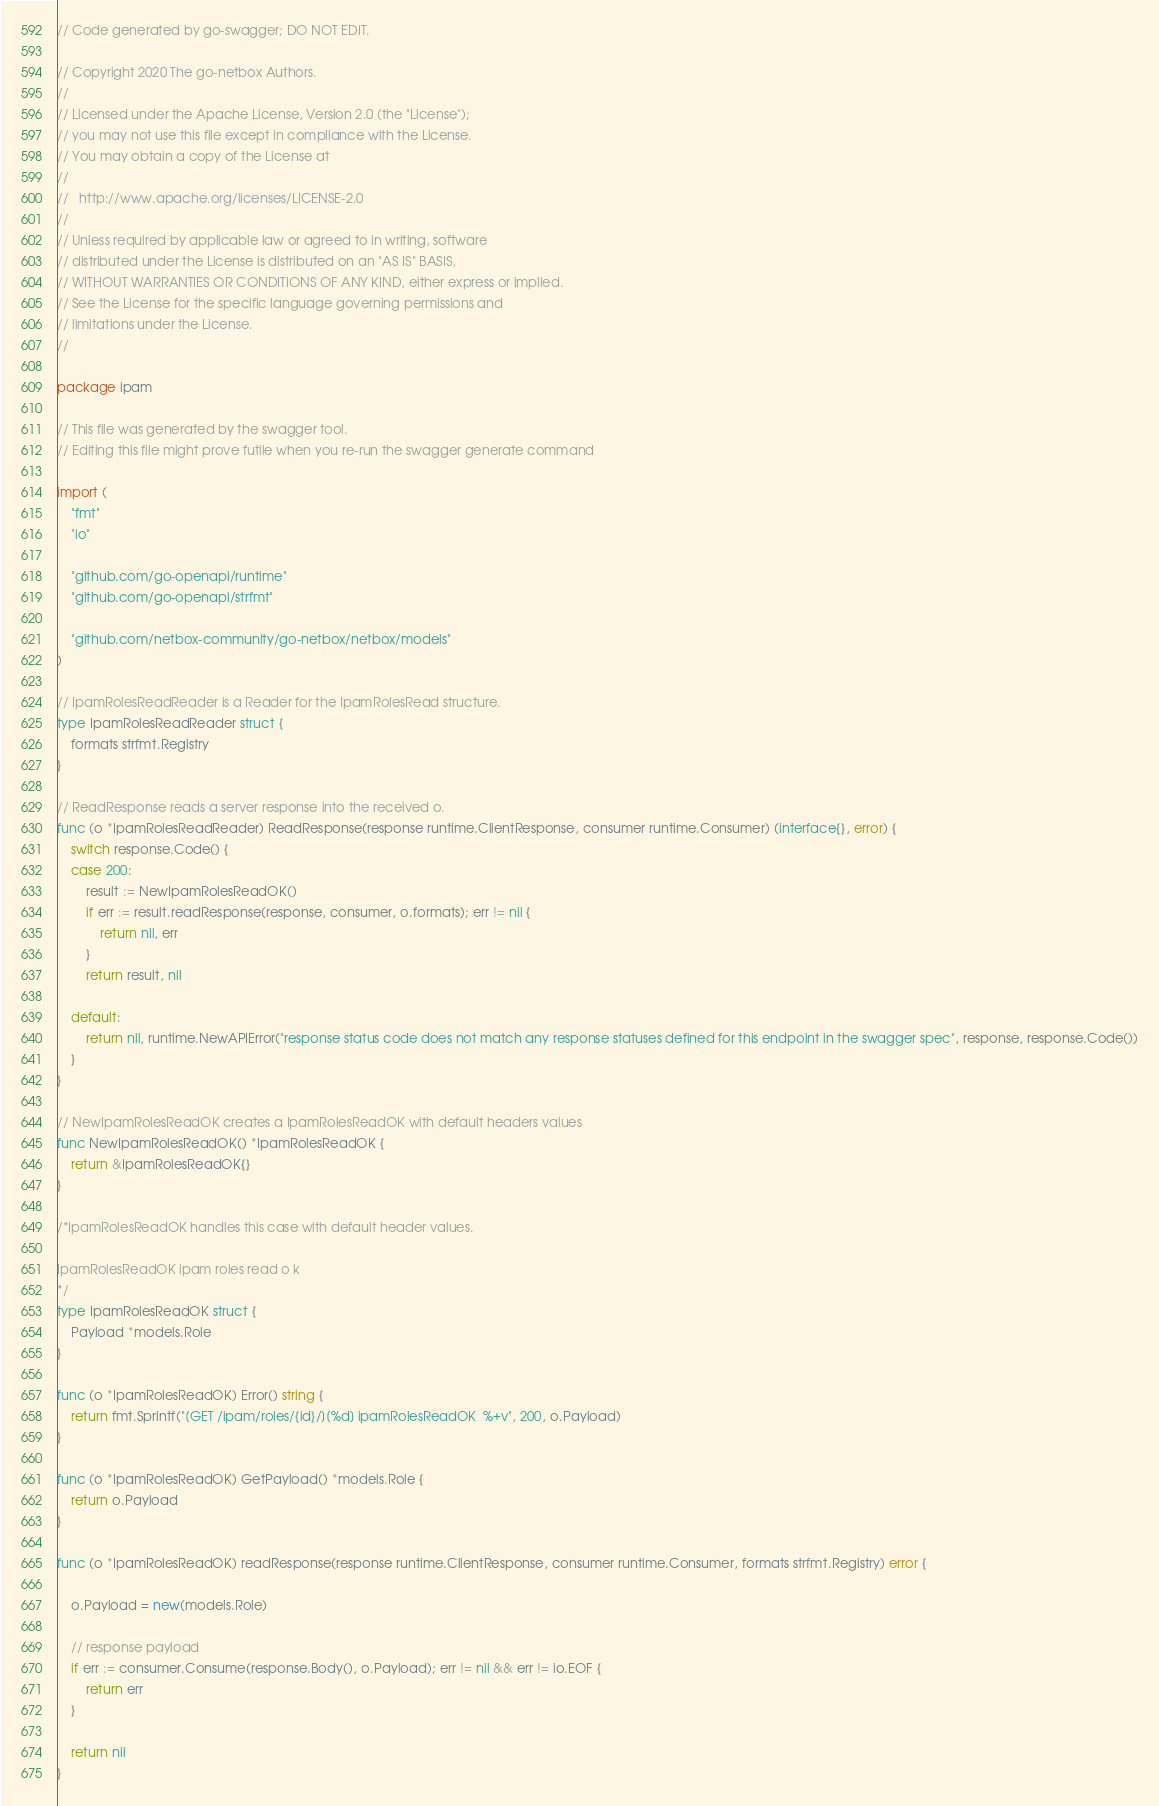Convert code to text. <code><loc_0><loc_0><loc_500><loc_500><_Go_>// Code generated by go-swagger; DO NOT EDIT.

// Copyright 2020 The go-netbox Authors.
//
// Licensed under the Apache License, Version 2.0 (the "License");
// you may not use this file except in compliance with the License.
// You may obtain a copy of the License at
//
//   http://www.apache.org/licenses/LICENSE-2.0
//
// Unless required by applicable law or agreed to in writing, software
// distributed under the License is distributed on an "AS IS" BASIS,
// WITHOUT WARRANTIES OR CONDITIONS OF ANY KIND, either express or implied.
// See the License for the specific language governing permissions and
// limitations under the License.
//

package ipam

// This file was generated by the swagger tool.
// Editing this file might prove futile when you re-run the swagger generate command

import (
	"fmt"
	"io"

	"github.com/go-openapi/runtime"
	"github.com/go-openapi/strfmt"

	"github.com/netbox-community/go-netbox/netbox/models"
)

// IpamRolesReadReader is a Reader for the IpamRolesRead structure.
type IpamRolesReadReader struct {
	formats strfmt.Registry
}

// ReadResponse reads a server response into the received o.
func (o *IpamRolesReadReader) ReadResponse(response runtime.ClientResponse, consumer runtime.Consumer) (interface{}, error) {
	switch response.Code() {
	case 200:
		result := NewIpamRolesReadOK()
		if err := result.readResponse(response, consumer, o.formats); err != nil {
			return nil, err
		}
		return result, nil

	default:
		return nil, runtime.NewAPIError("response status code does not match any response statuses defined for this endpoint in the swagger spec", response, response.Code())
	}
}

// NewIpamRolesReadOK creates a IpamRolesReadOK with default headers values
func NewIpamRolesReadOK() *IpamRolesReadOK {
	return &IpamRolesReadOK{}
}

/*IpamRolesReadOK handles this case with default header values.

IpamRolesReadOK ipam roles read o k
*/
type IpamRolesReadOK struct {
	Payload *models.Role
}

func (o *IpamRolesReadOK) Error() string {
	return fmt.Sprintf("[GET /ipam/roles/{id}/][%d] ipamRolesReadOK  %+v", 200, o.Payload)
}

func (o *IpamRolesReadOK) GetPayload() *models.Role {
	return o.Payload
}

func (o *IpamRolesReadOK) readResponse(response runtime.ClientResponse, consumer runtime.Consumer, formats strfmt.Registry) error {

	o.Payload = new(models.Role)

	// response payload
	if err := consumer.Consume(response.Body(), o.Payload); err != nil && err != io.EOF {
		return err
	}

	return nil
}
</code> 